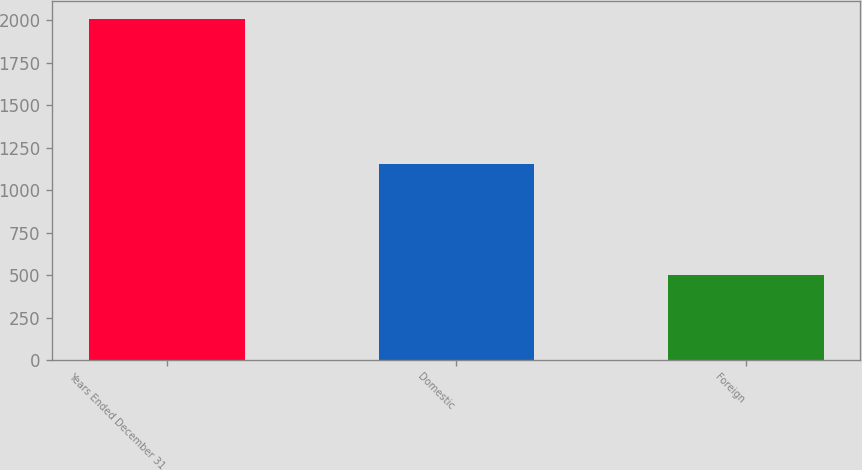Convert chart to OTSL. <chart><loc_0><loc_0><loc_500><loc_500><bar_chart><fcel>Years Ended December 31<fcel>Domestic<fcel>Foreign<nl><fcel>2010<fcel>1154<fcel>499<nl></chart> 